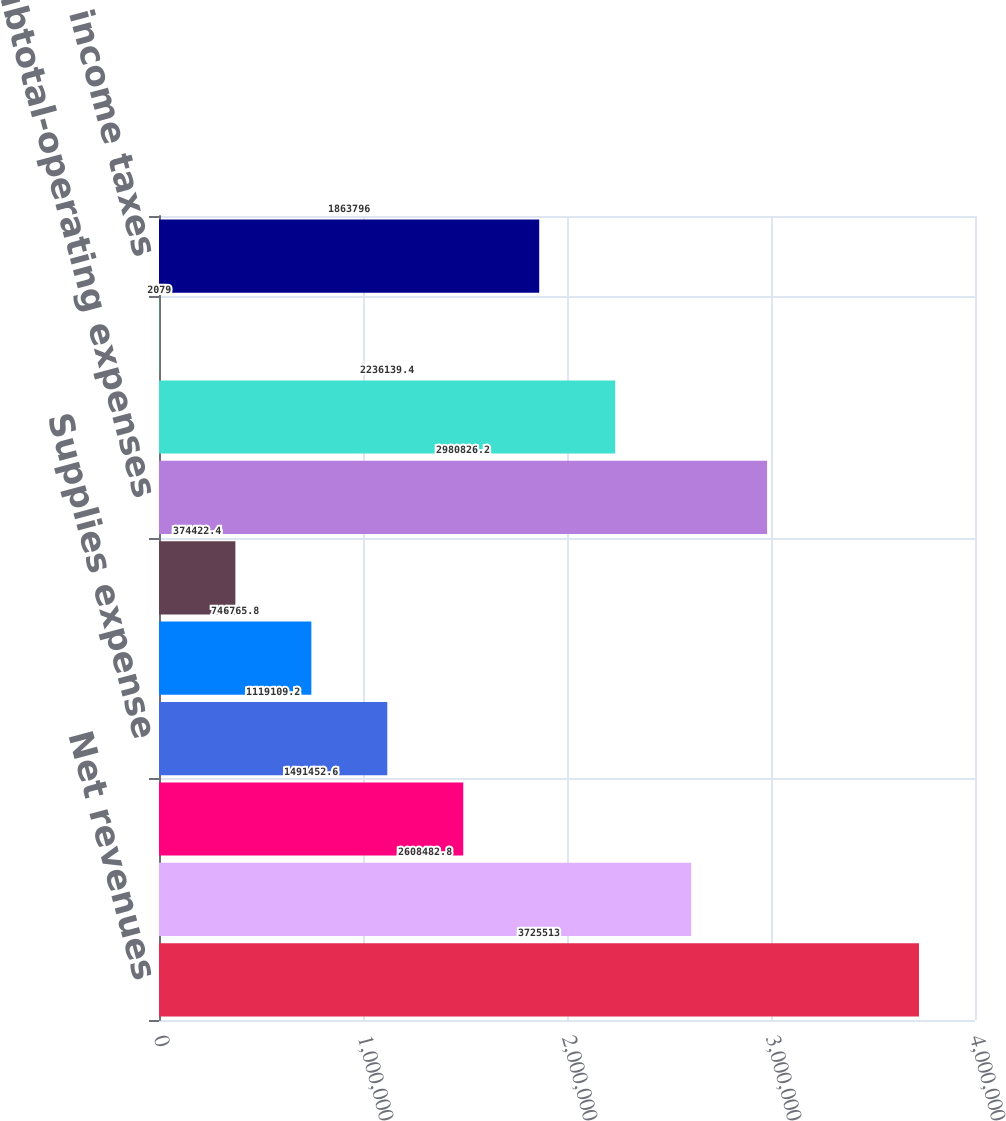Convert chart to OTSL. <chart><loc_0><loc_0><loc_500><loc_500><bar_chart><fcel>Net revenues<fcel>Salaries wages and benefits<fcel>Other operating expenses<fcel>Supplies expense<fcel>Depreciation and amortization<fcel>Lease and rental expense<fcel>Subtotal-operating expenses<fcel>Income from operations<fcel>Interest expense net<fcel>Income before income taxes<nl><fcel>3.72551e+06<fcel>2.60848e+06<fcel>1.49145e+06<fcel>1.11911e+06<fcel>746766<fcel>374422<fcel>2.98083e+06<fcel>2.23614e+06<fcel>2079<fcel>1.8638e+06<nl></chart> 